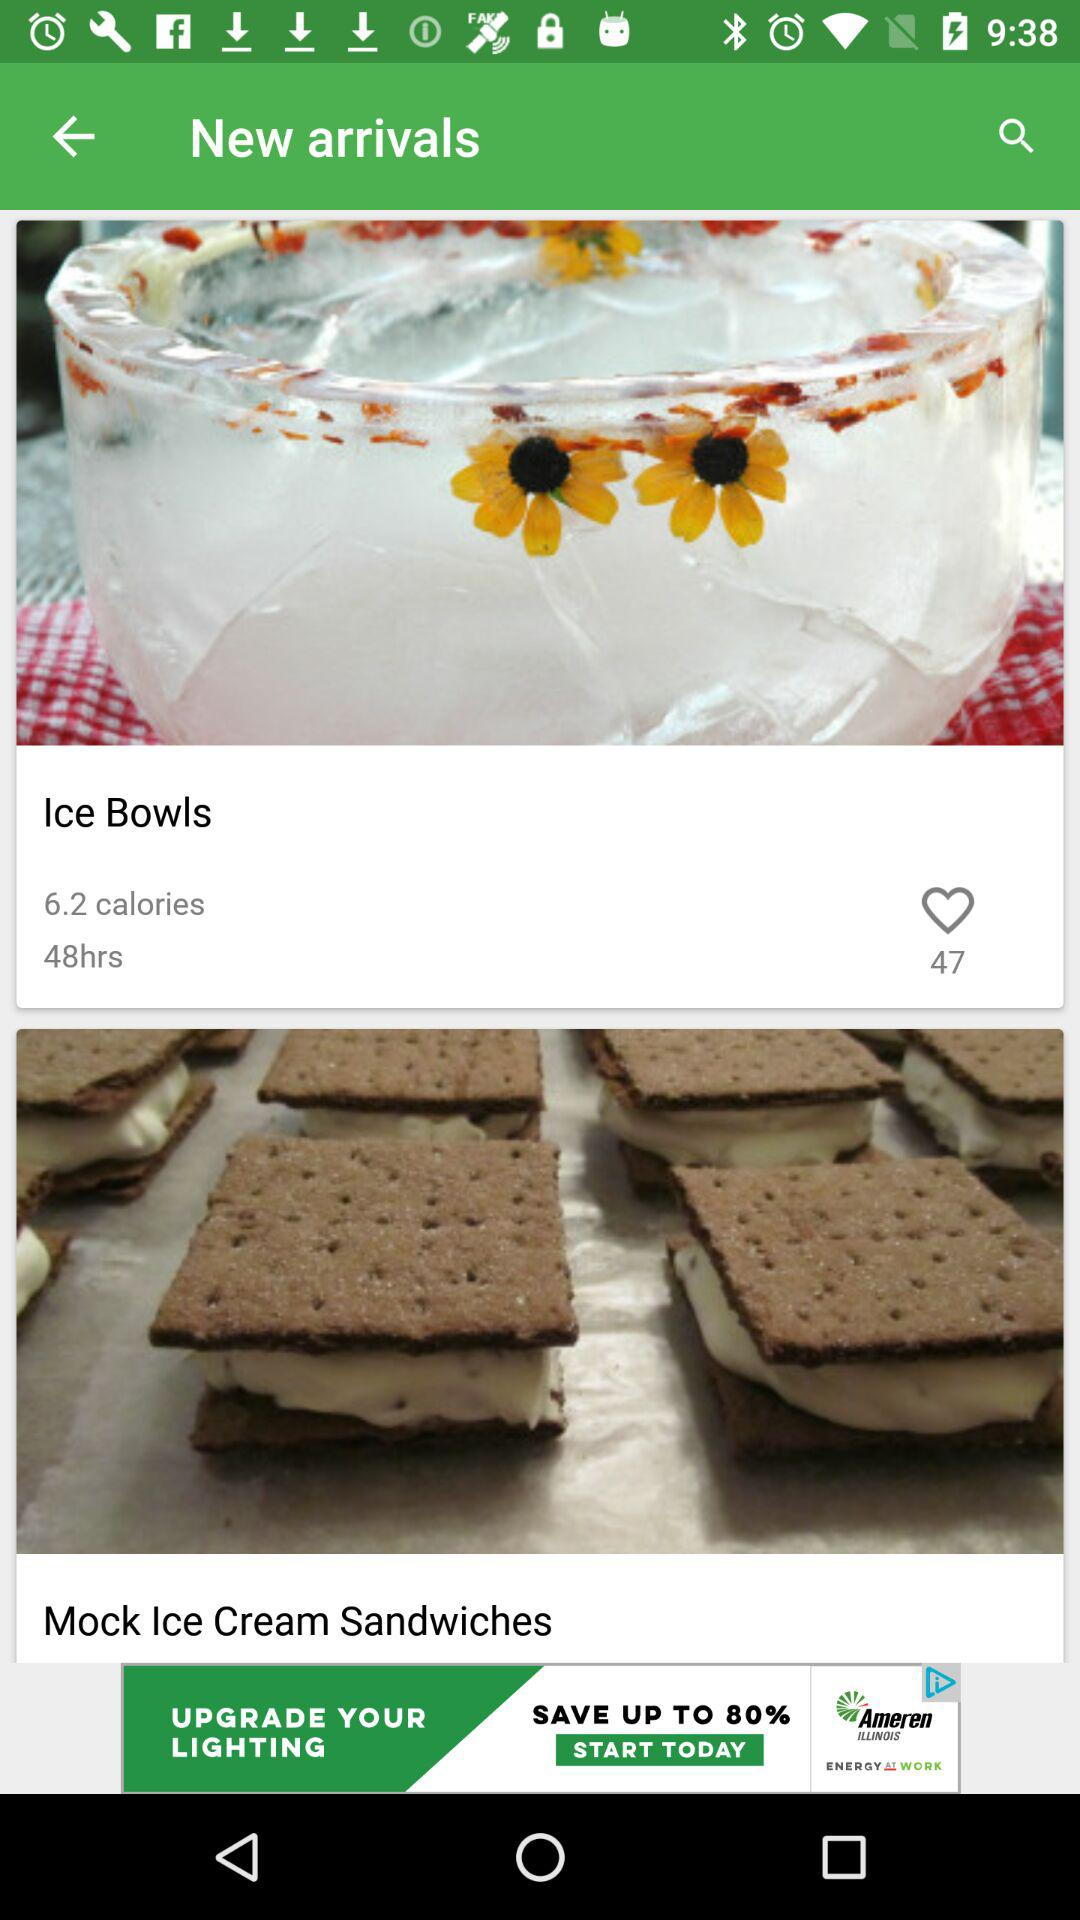What is the time required to prepare "Ice Bowls"? The time required to prepare "Ice Bowls" is 48 hours. 